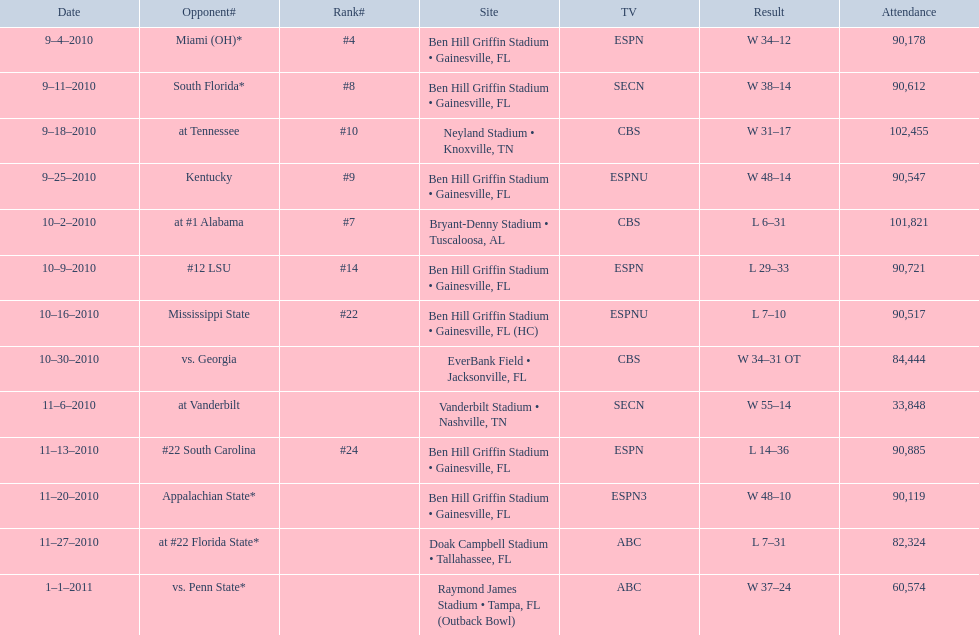What was the number of consecutive weeks the gators won in the 2010 season before they had their first loss? 4. 